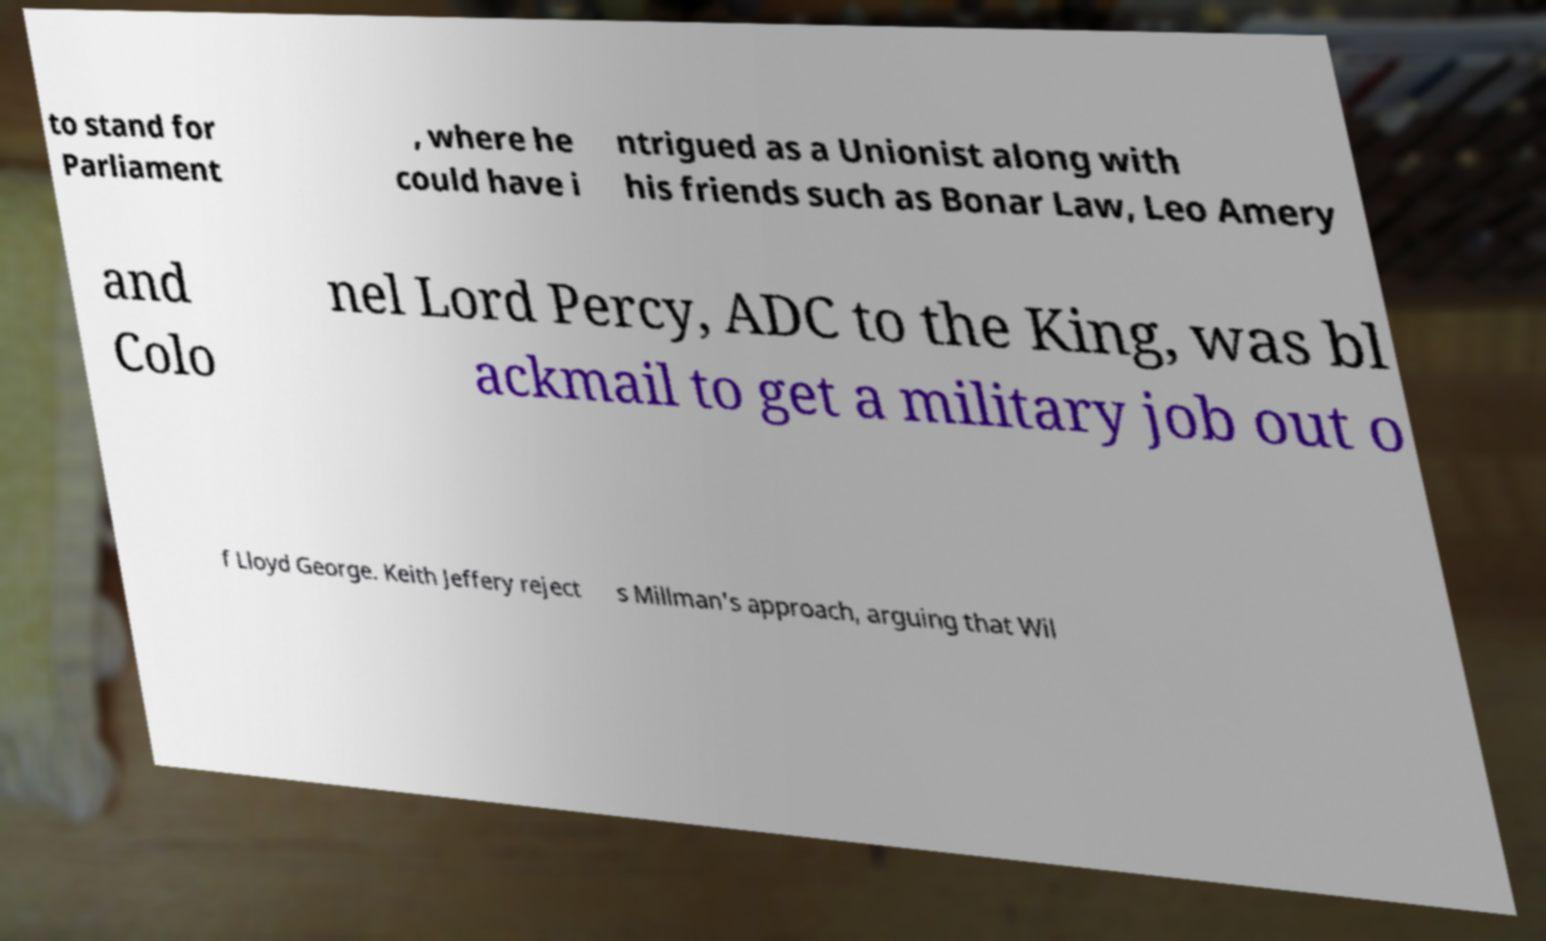There's text embedded in this image that I need extracted. Can you transcribe it verbatim? to stand for Parliament , where he could have i ntrigued as a Unionist along with his friends such as Bonar Law, Leo Amery and Colo nel Lord Percy, ADC to the King, was bl ackmail to get a military job out o f Lloyd George. Keith Jeffery reject s Millman's approach, arguing that Wil 